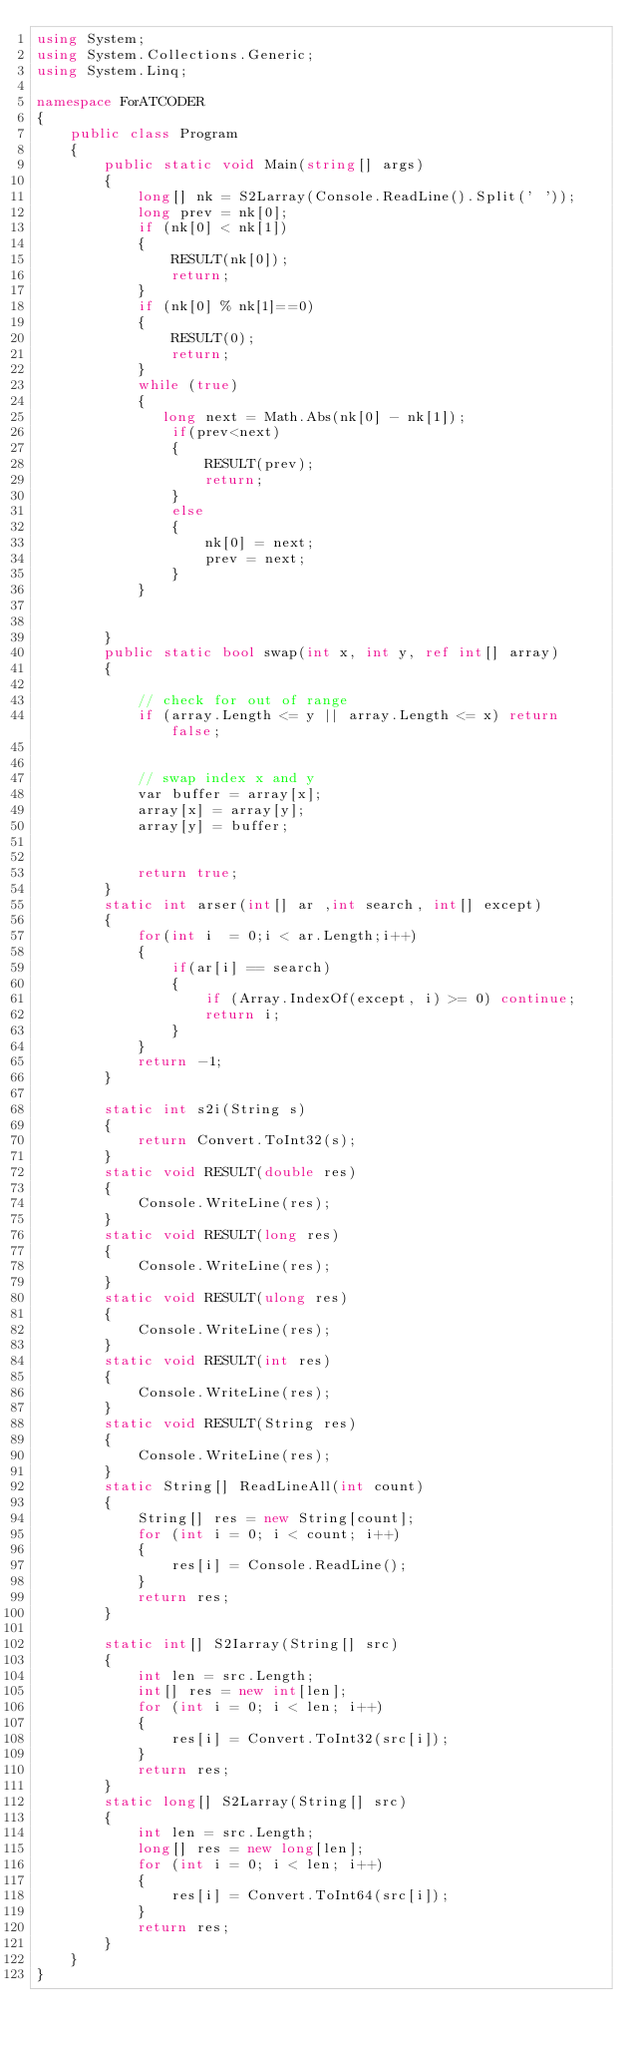<code> <loc_0><loc_0><loc_500><loc_500><_C#_>using System;
using System.Collections.Generic;
using System.Linq;

namespace ForATCODER
{
    public class Program
    {
        public static void Main(string[] args)
        {
            long[] nk = S2Larray(Console.ReadLine().Split(' '));
            long prev = nk[0];
            if (nk[0] < nk[1])
            {
                RESULT(nk[0]);
                return;
            }
            if (nk[0] % nk[1]==0)
            {
                RESULT(0);
                return;
            }
            while (true)
            {
               long next = Math.Abs(nk[0] - nk[1]);
                if(prev<next)
                {
                    RESULT(prev);
                    return;
                }
                else
                {
                    nk[0] = next;
                    prev = next;
                }
            }
         

        }
        public static bool swap(int x, int y, ref int[] array)
        {

            // check for out of range
            if (array.Length <= y || array.Length <= x) return false;


            // swap index x and y
            var buffer = array[x];
            array[x] = array[y];
            array[y] = buffer;


            return true;
        }
        static int arser(int[] ar ,int search, int[] except)
        {
            for(int i  = 0;i < ar.Length;i++)
            {
                if(ar[i] == search)
                {
                    if (Array.IndexOf(except, i) >= 0) continue;
                    return i;
                }
            }
            return -1;
        }

        static int s2i(String s)
        {
            return Convert.ToInt32(s);
        }
        static void RESULT(double res)
        {
            Console.WriteLine(res);
        }
        static void RESULT(long res)
        {
            Console.WriteLine(res);
        }
        static void RESULT(ulong res)
        {
            Console.WriteLine(res);
        }
        static void RESULT(int res)
        {
            Console.WriteLine(res);
        }
        static void RESULT(String res)
        {
            Console.WriteLine(res);
        }
        static String[] ReadLineAll(int count)
        {
            String[] res = new String[count];
            for (int i = 0; i < count; i++)
            {
                res[i] = Console.ReadLine();
            }
            return res;
        }

        static int[] S2Iarray(String[] src)
        {
            int len = src.Length;
            int[] res = new int[len];
            for (int i = 0; i < len; i++)
            {
                res[i] = Convert.ToInt32(src[i]);
            }
            return res;
        }
        static long[] S2Larray(String[] src)
        {
            int len = src.Length;
            long[] res = new long[len];
            for (int i = 0; i < len; i++)
            {
                res[i] = Convert.ToInt64(src[i]);
            }
            return res;
        }
    }
}
</code> 